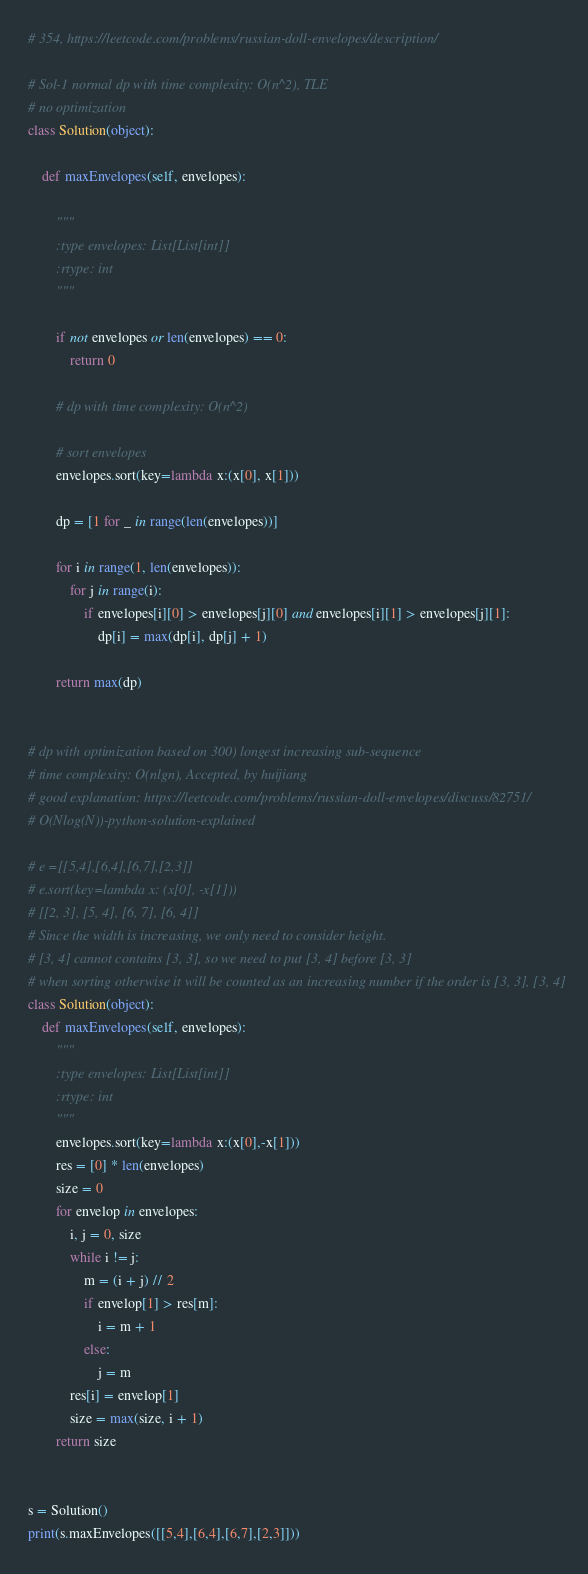Convert code to text. <code><loc_0><loc_0><loc_500><loc_500><_Python_># 354, https://leetcode.com/problems/russian-doll-envelopes/description/

# Sol-1 normal dp with time complexity: O(n^2), TLE
# no optimization
class Solution(object):

    def maxEnvelopes(self, envelopes):

        """
        :type envelopes: List[List[int]]
        :rtype: int
        """

        if not envelopes or len(envelopes) == 0:
            return 0

        # dp with time complexity: O(n^2)

        # sort envelopes
        envelopes.sort(key=lambda x:(x[0], x[1]))

        dp = [1 for _ in range(len(envelopes))]

        for i in range(1, len(envelopes)):
            for j in range(i):
                if envelopes[i][0] > envelopes[j][0] and envelopes[i][1] > envelopes[j][1]:
                    dp[i] = max(dp[i], dp[j] + 1)

        return max(dp)


# dp with optimization based on 300) longest increasing sub-sequence
# time complexity: O(nlgn), Accepted, by huijiang
# good explanation: https://leetcode.com/problems/russian-doll-envelopes/discuss/82751/
# O(Nlog(N))-python-solution-explained

# e =[[5,4],[6,4],[6,7],[2,3]]
# e.sort(key=lambda x: (x[0], -x[1]))
# [[2, 3], [5, 4], [6, 7], [6, 4]]
# Since the width is increasing, we only need to consider height.
# [3, 4] cannot contains [3, 3], so we need to put [3, 4] before [3, 3]
# when sorting otherwise it will be counted as an increasing number if the order is [3, 3], [3, 4]
class Solution(object):
    def maxEnvelopes(self, envelopes):
        """
        :type envelopes: List[List[int]]
        :rtype: int
        """
        envelopes.sort(key=lambda x:(x[0],-x[1]))
        res = [0] * len(envelopes)
        size = 0
        for envelop in envelopes:
            i, j = 0, size
            while i != j:
                m = (i + j) // 2
                if envelop[1] > res[m]:
                    i = m + 1
                else:
                    j = m
            res[i] = envelop[1]
            size = max(size, i + 1)
        return size


s = Solution()
print(s.maxEnvelopes([[5,4],[6,4],[6,7],[2,3]]))
</code> 